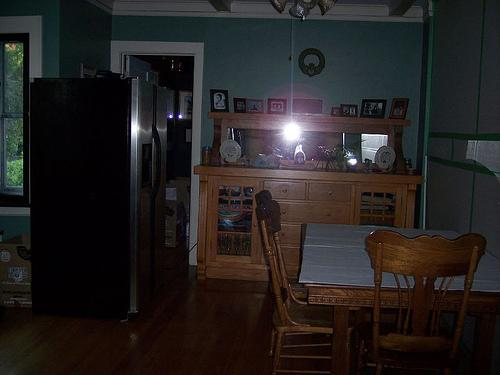What is the large silver object to the left used to store?

Choices:
A) animals
B) clothing
C) toys
D) food food 